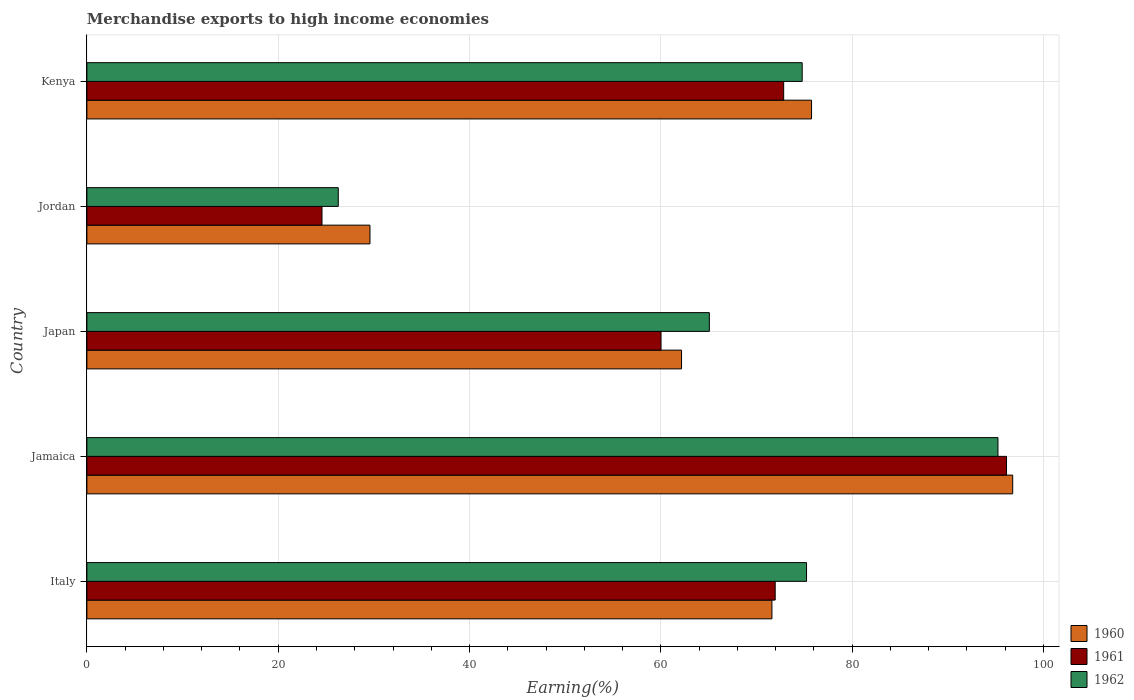How many groups of bars are there?
Provide a succinct answer. 5. Are the number of bars on each tick of the Y-axis equal?
Your answer should be very brief. Yes. How many bars are there on the 1st tick from the top?
Your answer should be very brief. 3. What is the label of the 4th group of bars from the top?
Offer a terse response. Jamaica. In how many cases, is the number of bars for a given country not equal to the number of legend labels?
Your answer should be compact. 0. What is the percentage of amount earned from merchandise exports in 1961 in Italy?
Offer a terse response. 71.95. Across all countries, what is the maximum percentage of amount earned from merchandise exports in 1962?
Offer a terse response. 95.24. Across all countries, what is the minimum percentage of amount earned from merchandise exports in 1962?
Your response must be concise. 26.28. In which country was the percentage of amount earned from merchandise exports in 1962 maximum?
Give a very brief answer. Jamaica. In which country was the percentage of amount earned from merchandise exports in 1962 minimum?
Your answer should be compact. Jordan. What is the total percentage of amount earned from merchandise exports in 1960 in the graph?
Provide a short and direct response. 335.9. What is the difference between the percentage of amount earned from merchandise exports in 1961 in Italy and that in Jordan?
Give a very brief answer. 47.38. What is the difference between the percentage of amount earned from merchandise exports in 1961 in Kenya and the percentage of amount earned from merchandise exports in 1962 in Jamaica?
Your answer should be very brief. -22.4. What is the average percentage of amount earned from merchandise exports in 1960 per country?
Ensure brevity in your answer.  67.18. What is the difference between the percentage of amount earned from merchandise exports in 1960 and percentage of amount earned from merchandise exports in 1962 in Kenya?
Provide a short and direct response. 0.98. What is the ratio of the percentage of amount earned from merchandise exports in 1962 in Jamaica to that in Japan?
Your response must be concise. 1.46. Is the difference between the percentage of amount earned from merchandise exports in 1960 in Japan and Jordan greater than the difference between the percentage of amount earned from merchandise exports in 1962 in Japan and Jordan?
Your answer should be very brief. No. What is the difference between the highest and the second highest percentage of amount earned from merchandise exports in 1961?
Your response must be concise. 23.3. What is the difference between the highest and the lowest percentage of amount earned from merchandise exports in 1961?
Offer a terse response. 71.56. What does the 3rd bar from the top in Jamaica represents?
Give a very brief answer. 1960. What does the 3rd bar from the bottom in Jamaica represents?
Ensure brevity in your answer.  1962. Are all the bars in the graph horizontal?
Provide a short and direct response. Yes. How many countries are there in the graph?
Your answer should be compact. 5. What is the difference between two consecutive major ticks on the X-axis?
Provide a short and direct response. 20. Are the values on the major ticks of X-axis written in scientific E-notation?
Ensure brevity in your answer.  No. Does the graph contain any zero values?
Provide a short and direct response. No. Where does the legend appear in the graph?
Provide a succinct answer. Bottom right. How many legend labels are there?
Offer a very short reply. 3. What is the title of the graph?
Give a very brief answer. Merchandise exports to high income economies. What is the label or title of the X-axis?
Make the answer very short. Earning(%). What is the Earning(%) of 1960 in Italy?
Offer a terse response. 71.61. What is the Earning(%) of 1961 in Italy?
Make the answer very short. 71.95. What is the Earning(%) in 1962 in Italy?
Your answer should be very brief. 75.23. What is the Earning(%) in 1960 in Jamaica?
Your response must be concise. 96.78. What is the Earning(%) in 1961 in Jamaica?
Give a very brief answer. 96.13. What is the Earning(%) in 1962 in Jamaica?
Give a very brief answer. 95.24. What is the Earning(%) of 1960 in Japan?
Ensure brevity in your answer.  62.16. What is the Earning(%) of 1961 in Japan?
Give a very brief answer. 60.02. What is the Earning(%) of 1962 in Japan?
Offer a terse response. 65.07. What is the Earning(%) in 1960 in Jordan?
Give a very brief answer. 29.59. What is the Earning(%) in 1961 in Jordan?
Offer a very short reply. 24.58. What is the Earning(%) in 1962 in Jordan?
Offer a terse response. 26.28. What is the Earning(%) of 1960 in Kenya?
Keep it short and to the point. 75.75. What is the Earning(%) of 1961 in Kenya?
Ensure brevity in your answer.  72.84. What is the Earning(%) of 1962 in Kenya?
Your answer should be compact. 74.77. Across all countries, what is the maximum Earning(%) of 1960?
Offer a terse response. 96.78. Across all countries, what is the maximum Earning(%) in 1961?
Your answer should be very brief. 96.13. Across all countries, what is the maximum Earning(%) in 1962?
Your answer should be very brief. 95.24. Across all countries, what is the minimum Earning(%) of 1960?
Make the answer very short. 29.59. Across all countries, what is the minimum Earning(%) of 1961?
Provide a short and direct response. 24.58. Across all countries, what is the minimum Earning(%) of 1962?
Your answer should be very brief. 26.28. What is the total Earning(%) in 1960 in the graph?
Make the answer very short. 335.9. What is the total Earning(%) in 1961 in the graph?
Your response must be concise. 325.52. What is the total Earning(%) of 1962 in the graph?
Offer a terse response. 336.59. What is the difference between the Earning(%) in 1960 in Italy and that in Jamaica?
Offer a terse response. -25.17. What is the difference between the Earning(%) in 1961 in Italy and that in Jamaica?
Provide a succinct answer. -24.18. What is the difference between the Earning(%) of 1962 in Italy and that in Jamaica?
Ensure brevity in your answer.  -20.01. What is the difference between the Earning(%) in 1960 in Italy and that in Japan?
Provide a short and direct response. 9.45. What is the difference between the Earning(%) in 1961 in Italy and that in Japan?
Your answer should be compact. 11.93. What is the difference between the Earning(%) in 1962 in Italy and that in Japan?
Offer a very short reply. 10.16. What is the difference between the Earning(%) of 1960 in Italy and that in Jordan?
Offer a terse response. 42.02. What is the difference between the Earning(%) of 1961 in Italy and that in Jordan?
Your response must be concise. 47.38. What is the difference between the Earning(%) in 1962 in Italy and that in Jordan?
Give a very brief answer. 48.95. What is the difference between the Earning(%) of 1960 in Italy and that in Kenya?
Offer a terse response. -4.14. What is the difference between the Earning(%) in 1961 in Italy and that in Kenya?
Your answer should be very brief. -0.89. What is the difference between the Earning(%) of 1962 in Italy and that in Kenya?
Your answer should be very brief. 0.45. What is the difference between the Earning(%) of 1960 in Jamaica and that in Japan?
Your answer should be compact. 34.62. What is the difference between the Earning(%) of 1961 in Jamaica and that in Japan?
Give a very brief answer. 36.12. What is the difference between the Earning(%) of 1962 in Jamaica and that in Japan?
Give a very brief answer. 30.17. What is the difference between the Earning(%) of 1960 in Jamaica and that in Jordan?
Provide a short and direct response. 67.19. What is the difference between the Earning(%) of 1961 in Jamaica and that in Jordan?
Make the answer very short. 71.56. What is the difference between the Earning(%) in 1962 in Jamaica and that in Jordan?
Provide a succinct answer. 68.96. What is the difference between the Earning(%) in 1960 in Jamaica and that in Kenya?
Offer a very short reply. 21.03. What is the difference between the Earning(%) of 1961 in Jamaica and that in Kenya?
Offer a terse response. 23.3. What is the difference between the Earning(%) in 1962 in Jamaica and that in Kenya?
Offer a terse response. 20.47. What is the difference between the Earning(%) in 1960 in Japan and that in Jordan?
Your answer should be very brief. 32.57. What is the difference between the Earning(%) of 1961 in Japan and that in Jordan?
Your answer should be compact. 35.44. What is the difference between the Earning(%) in 1962 in Japan and that in Jordan?
Provide a short and direct response. 38.79. What is the difference between the Earning(%) in 1960 in Japan and that in Kenya?
Ensure brevity in your answer.  -13.59. What is the difference between the Earning(%) in 1961 in Japan and that in Kenya?
Offer a terse response. -12.82. What is the difference between the Earning(%) of 1962 in Japan and that in Kenya?
Provide a short and direct response. -9.7. What is the difference between the Earning(%) in 1960 in Jordan and that in Kenya?
Make the answer very short. -46.16. What is the difference between the Earning(%) of 1961 in Jordan and that in Kenya?
Make the answer very short. -48.26. What is the difference between the Earning(%) in 1962 in Jordan and that in Kenya?
Provide a succinct answer. -48.5. What is the difference between the Earning(%) in 1960 in Italy and the Earning(%) in 1961 in Jamaica?
Give a very brief answer. -24.52. What is the difference between the Earning(%) of 1960 in Italy and the Earning(%) of 1962 in Jamaica?
Your response must be concise. -23.63. What is the difference between the Earning(%) in 1961 in Italy and the Earning(%) in 1962 in Jamaica?
Make the answer very short. -23.29. What is the difference between the Earning(%) in 1960 in Italy and the Earning(%) in 1961 in Japan?
Your response must be concise. 11.59. What is the difference between the Earning(%) in 1960 in Italy and the Earning(%) in 1962 in Japan?
Give a very brief answer. 6.54. What is the difference between the Earning(%) in 1961 in Italy and the Earning(%) in 1962 in Japan?
Give a very brief answer. 6.88. What is the difference between the Earning(%) of 1960 in Italy and the Earning(%) of 1961 in Jordan?
Offer a terse response. 47.03. What is the difference between the Earning(%) in 1960 in Italy and the Earning(%) in 1962 in Jordan?
Your answer should be very brief. 45.33. What is the difference between the Earning(%) in 1961 in Italy and the Earning(%) in 1962 in Jordan?
Your answer should be very brief. 45.67. What is the difference between the Earning(%) in 1960 in Italy and the Earning(%) in 1961 in Kenya?
Your response must be concise. -1.23. What is the difference between the Earning(%) in 1960 in Italy and the Earning(%) in 1962 in Kenya?
Your answer should be compact. -3.16. What is the difference between the Earning(%) of 1961 in Italy and the Earning(%) of 1962 in Kenya?
Your answer should be compact. -2.82. What is the difference between the Earning(%) in 1960 in Jamaica and the Earning(%) in 1961 in Japan?
Ensure brevity in your answer.  36.76. What is the difference between the Earning(%) in 1960 in Jamaica and the Earning(%) in 1962 in Japan?
Ensure brevity in your answer.  31.71. What is the difference between the Earning(%) in 1961 in Jamaica and the Earning(%) in 1962 in Japan?
Provide a short and direct response. 31.06. What is the difference between the Earning(%) of 1960 in Jamaica and the Earning(%) of 1961 in Jordan?
Offer a terse response. 72.2. What is the difference between the Earning(%) in 1960 in Jamaica and the Earning(%) in 1962 in Jordan?
Your answer should be compact. 70.5. What is the difference between the Earning(%) of 1961 in Jamaica and the Earning(%) of 1962 in Jordan?
Offer a terse response. 69.86. What is the difference between the Earning(%) in 1960 in Jamaica and the Earning(%) in 1961 in Kenya?
Offer a very short reply. 23.94. What is the difference between the Earning(%) of 1960 in Jamaica and the Earning(%) of 1962 in Kenya?
Keep it short and to the point. 22.01. What is the difference between the Earning(%) in 1961 in Jamaica and the Earning(%) in 1962 in Kenya?
Provide a short and direct response. 21.36. What is the difference between the Earning(%) of 1960 in Japan and the Earning(%) of 1961 in Jordan?
Make the answer very short. 37.59. What is the difference between the Earning(%) in 1960 in Japan and the Earning(%) in 1962 in Jordan?
Your answer should be very brief. 35.89. What is the difference between the Earning(%) in 1961 in Japan and the Earning(%) in 1962 in Jordan?
Provide a succinct answer. 33.74. What is the difference between the Earning(%) of 1960 in Japan and the Earning(%) of 1961 in Kenya?
Keep it short and to the point. -10.68. What is the difference between the Earning(%) of 1960 in Japan and the Earning(%) of 1962 in Kenya?
Provide a succinct answer. -12.61. What is the difference between the Earning(%) of 1961 in Japan and the Earning(%) of 1962 in Kenya?
Keep it short and to the point. -14.76. What is the difference between the Earning(%) in 1960 in Jordan and the Earning(%) in 1961 in Kenya?
Keep it short and to the point. -43.25. What is the difference between the Earning(%) of 1960 in Jordan and the Earning(%) of 1962 in Kenya?
Offer a very short reply. -45.18. What is the difference between the Earning(%) in 1961 in Jordan and the Earning(%) in 1962 in Kenya?
Give a very brief answer. -50.2. What is the average Earning(%) in 1960 per country?
Your answer should be very brief. 67.18. What is the average Earning(%) of 1961 per country?
Provide a succinct answer. 65.1. What is the average Earning(%) of 1962 per country?
Provide a short and direct response. 67.32. What is the difference between the Earning(%) of 1960 and Earning(%) of 1961 in Italy?
Your answer should be very brief. -0.34. What is the difference between the Earning(%) in 1960 and Earning(%) in 1962 in Italy?
Your answer should be very brief. -3.62. What is the difference between the Earning(%) in 1961 and Earning(%) in 1962 in Italy?
Give a very brief answer. -3.28. What is the difference between the Earning(%) of 1960 and Earning(%) of 1961 in Jamaica?
Provide a short and direct response. 0.65. What is the difference between the Earning(%) in 1960 and Earning(%) in 1962 in Jamaica?
Ensure brevity in your answer.  1.54. What is the difference between the Earning(%) in 1961 and Earning(%) in 1962 in Jamaica?
Your answer should be compact. 0.89. What is the difference between the Earning(%) in 1960 and Earning(%) in 1961 in Japan?
Provide a succinct answer. 2.15. What is the difference between the Earning(%) of 1960 and Earning(%) of 1962 in Japan?
Your answer should be very brief. -2.91. What is the difference between the Earning(%) of 1961 and Earning(%) of 1962 in Japan?
Your response must be concise. -5.05. What is the difference between the Earning(%) of 1960 and Earning(%) of 1961 in Jordan?
Offer a very short reply. 5.02. What is the difference between the Earning(%) in 1960 and Earning(%) in 1962 in Jordan?
Provide a succinct answer. 3.31. What is the difference between the Earning(%) in 1961 and Earning(%) in 1962 in Jordan?
Your answer should be very brief. -1.7. What is the difference between the Earning(%) of 1960 and Earning(%) of 1961 in Kenya?
Give a very brief answer. 2.91. What is the difference between the Earning(%) in 1960 and Earning(%) in 1962 in Kenya?
Make the answer very short. 0.98. What is the difference between the Earning(%) in 1961 and Earning(%) in 1962 in Kenya?
Keep it short and to the point. -1.94. What is the ratio of the Earning(%) in 1960 in Italy to that in Jamaica?
Make the answer very short. 0.74. What is the ratio of the Earning(%) of 1961 in Italy to that in Jamaica?
Make the answer very short. 0.75. What is the ratio of the Earning(%) in 1962 in Italy to that in Jamaica?
Your response must be concise. 0.79. What is the ratio of the Earning(%) of 1960 in Italy to that in Japan?
Give a very brief answer. 1.15. What is the ratio of the Earning(%) in 1961 in Italy to that in Japan?
Ensure brevity in your answer.  1.2. What is the ratio of the Earning(%) of 1962 in Italy to that in Japan?
Your response must be concise. 1.16. What is the ratio of the Earning(%) in 1960 in Italy to that in Jordan?
Your answer should be compact. 2.42. What is the ratio of the Earning(%) in 1961 in Italy to that in Jordan?
Your response must be concise. 2.93. What is the ratio of the Earning(%) of 1962 in Italy to that in Jordan?
Give a very brief answer. 2.86. What is the ratio of the Earning(%) of 1960 in Italy to that in Kenya?
Your response must be concise. 0.95. What is the ratio of the Earning(%) in 1961 in Italy to that in Kenya?
Your response must be concise. 0.99. What is the ratio of the Earning(%) of 1962 in Italy to that in Kenya?
Make the answer very short. 1.01. What is the ratio of the Earning(%) in 1960 in Jamaica to that in Japan?
Keep it short and to the point. 1.56. What is the ratio of the Earning(%) of 1961 in Jamaica to that in Japan?
Offer a terse response. 1.6. What is the ratio of the Earning(%) of 1962 in Jamaica to that in Japan?
Your response must be concise. 1.46. What is the ratio of the Earning(%) in 1960 in Jamaica to that in Jordan?
Your response must be concise. 3.27. What is the ratio of the Earning(%) of 1961 in Jamaica to that in Jordan?
Your answer should be compact. 3.91. What is the ratio of the Earning(%) in 1962 in Jamaica to that in Jordan?
Ensure brevity in your answer.  3.62. What is the ratio of the Earning(%) in 1960 in Jamaica to that in Kenya?
Your response must be concise. 1.28. What is the ratio of the Earning(%) in 1961 in Jamaica to that in Kenya?
Offer a very short reply. 1.32. What is the ratio of the Earning(%) in 1962 in Jamaica to that in Kenya?
Provide a succinct answer. 1.27. What is the ratio of the Earning(%) in 1960 in Japan to that in Jordan?
Offer a terse response. 2.1. What is the ratio of the Earning(%) of 1961 in Japan to that in Jordan?
Your response must be concise. 2.44. What is the ratio of the Earning(%) in 1962 in Japan to that in Jordan?
Keep it short and to the point. 2.48. What is the ratio of the Earning(%) of 1960 in Japan to that in Kenya?
Provide a short and direct response. 0.82. What is the ratio of the Earning(%) of 1961 in Japan to that in Kenya?
Make the answer very short. 0.82. What is the ratio of the Earning(%) of 1962 in Japan to that in Kenya?
Offer a very short reply. 0.87. What is the ratio of the Earning(%) of 1960 in Jordan to that in Kenya?
Provide a succinct answer. 0.39. What is the ratio of the Earning(%) of 1961 in Jordan to that in Kenya?
Give a very brief answer. 0.34. What is the ratio of the Earning(%) of 1962 in Jordan to that in Kenya?
Offer a very short reply. 0.35. What is the difference between the highest and the second highest Earning(%) of 1960?
Keep it short and to the point. 21.03. What is the difference between the highest and the second highest Earning(%) in 1961?
Offer a very short reply. 23.3. What is the difference between the highest and the second highest Earning(%) of 1962?
Give a very brief answer. 20.01. What is the difference between the highest and the lowest Earning(%) of 1960?
Offer a terse response. 67.19. What is the difference between the highest and the lowest Earning(%) in 1961?
Your answer should be very brief. 71.56. What is the difference between the highest and the lowest Earning(%) in 1962?
Provide a short and direct response. 68.96. 